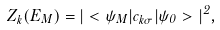<formula> <loc_0><loc_0><loc_500><loc_500>Z _ { k } ( E _ { M } ) = | < \psi _ { M } | c _ { k \sigma } | \psi _ { 0 } > | ^ { 2 } ,</formula> 